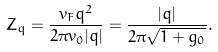<formula> <loc_0><loc_0><loc_500><loc_500>Z _ { q } = \frac { v _ { F } q ^ { 2 } } { 2 \pi v _ { 0 } | q | } = \frac { | q | } { 2 \pi \sqrt { 1 + g _ { 0 } } } .</formula> 